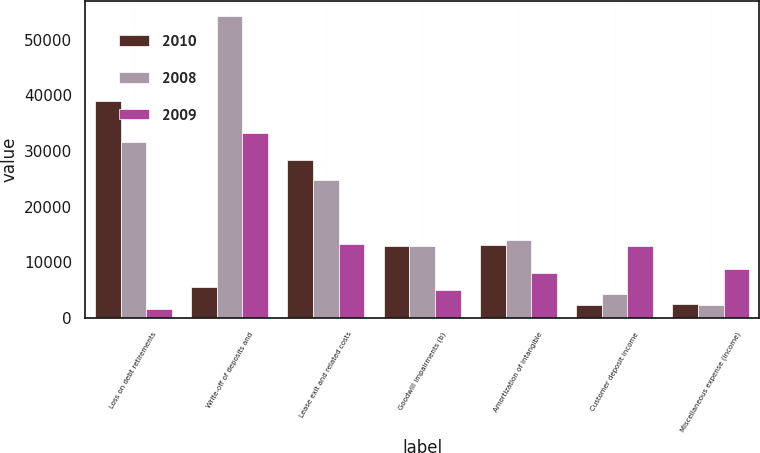Convert chart to OTSL. <chart><loc_0><loc_0><loc_500><loc_500><stacked_bar_chart><ecel><fcel>Loss on debt retirements<fcel>Write-off of deposits and<fcel>Lease exit and related costs<fcel>Goodwill impairments (b)<fcel>Amortization of intangible<fcel>Customer deposit income<fcel>Miscellaneous expense (income)<nl><fcel>2010<fcel>38920<fcel>5594<fcel>28378<fcel>12960<fcel>13099<fcel>2314<fcel>2410<nl><fcel>2008<fcel>31594<fcel>54256<fcel>24803<fcel>12960<fcel>14008<fcel>4213<fcel>2391<nl><fcel>2009<fcel>1594<fcel>33309<fcel>13260<fcel>4954<fcel>8151<fcel>12960<fcel>8737<nl></chart> 